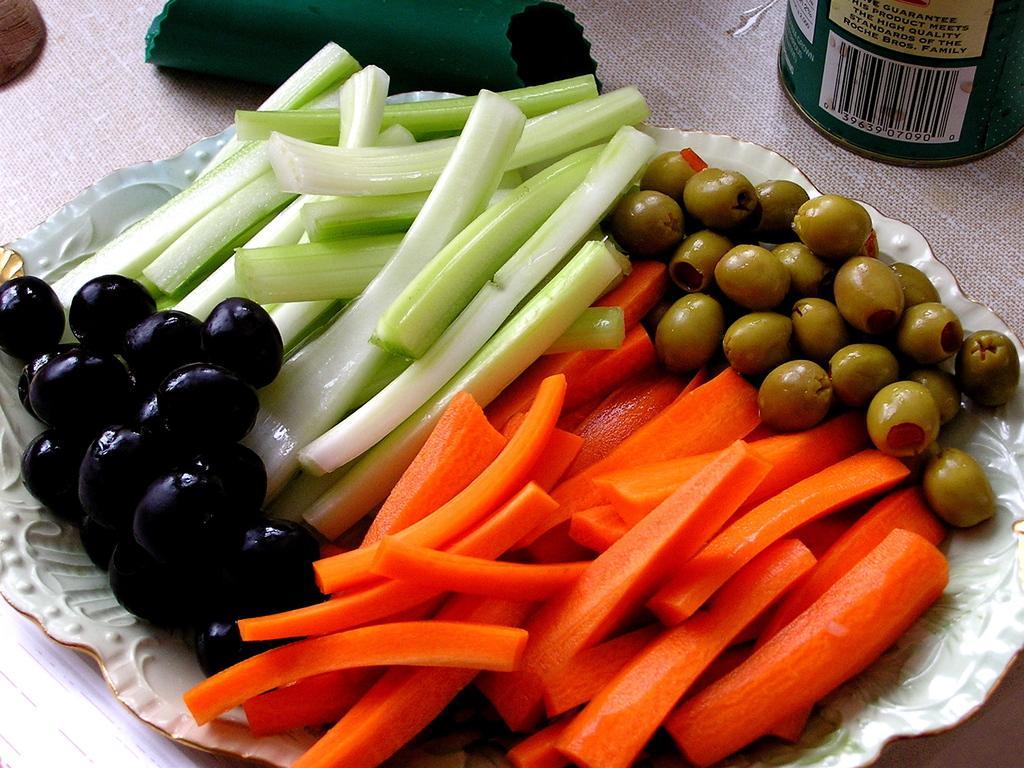How would you summarize this image in a sentence or two? In this image there are olives, sliced carrots and some other fruits and vegetables in a tray on a table, beside the tree there is a can and some other objects. 